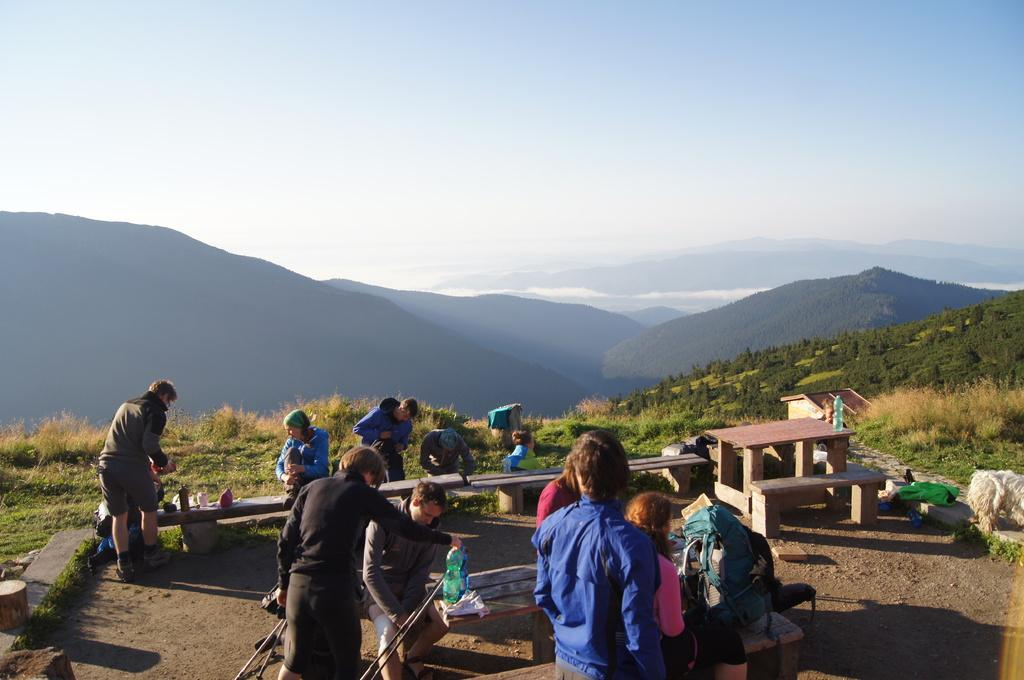What can be seen in the image in terms of people? There are groups of people in the image. What type of seating is available in the image? There are benches in the image. What objects are present that might be used for drinking? There are bottles in the image. What objects are present that might be used for activities like cooking or camping? There are sticks in the image. What can be seen in the background of the image? Hills, grass, and the sky are visible in the background of the image. What direction is the bee flying in the image? There is no bee present in the image. What type of juice is being served in the image? There is no juice present in the image. 